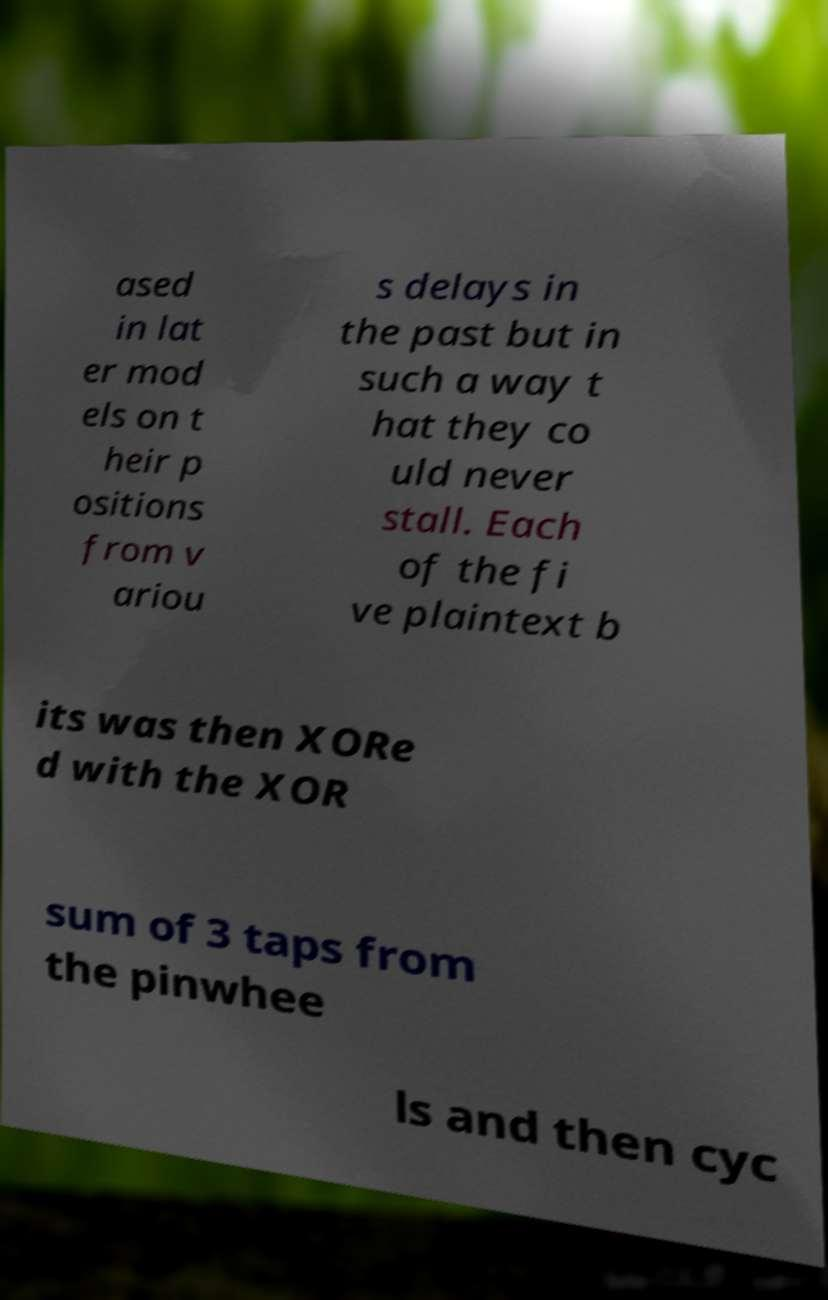Please read and relay the text visible in this image. What does it say? ased in lat er mod els on t heir p ositions from v ariou s delays in the past but in such a way t hat they co uld never stall. Each of the fi ve plaintext b its was then XORe d with the XOR sum of 3 taps from the pinwhee ls and then cyc 